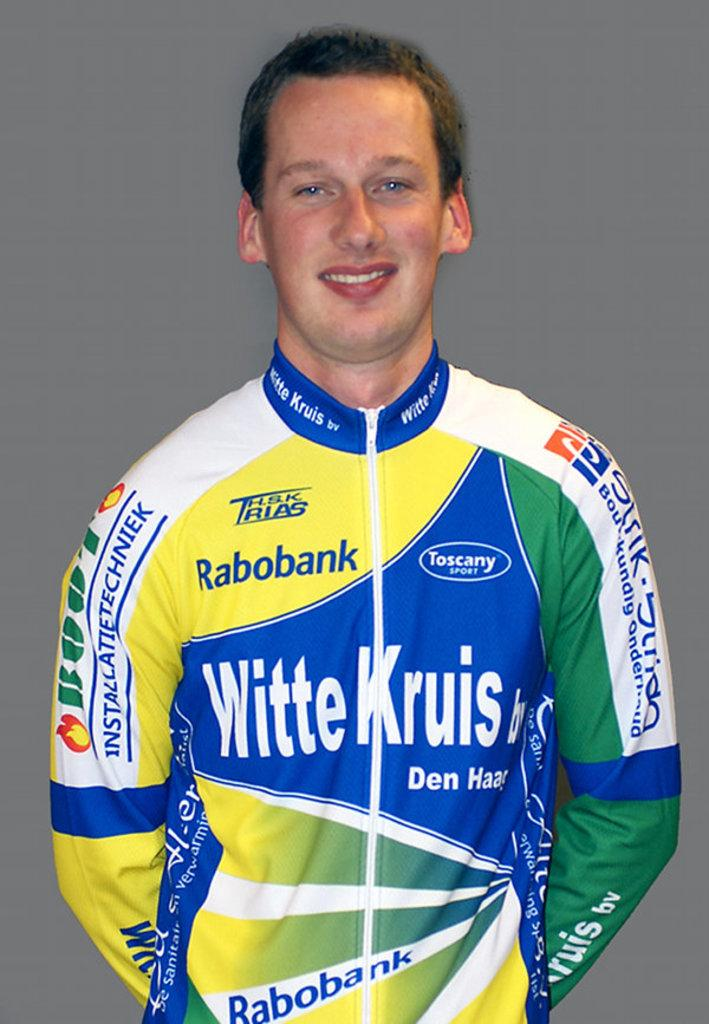<image>
Describe the image concisely. A man stands smiling wearing a jersey with Rabobank, WitteKruis, and Toscany sports on it. 